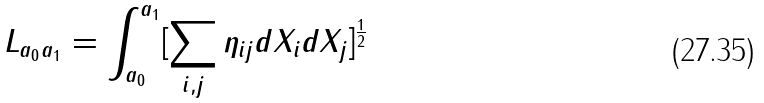Convert formula to latex. <formula><loc_0><loc_0><loc_500><loc_500>L _ { a _ { 0 } a _ { 1 } } = \int ^ { a _ { 1 } } _ { a _ { 0 } } [ \sum _ { i , j } { \eta _ { i j } d X _ { i } d X _ { j } } ] ^ { \frac { 1 } { 2 } }</formula> 